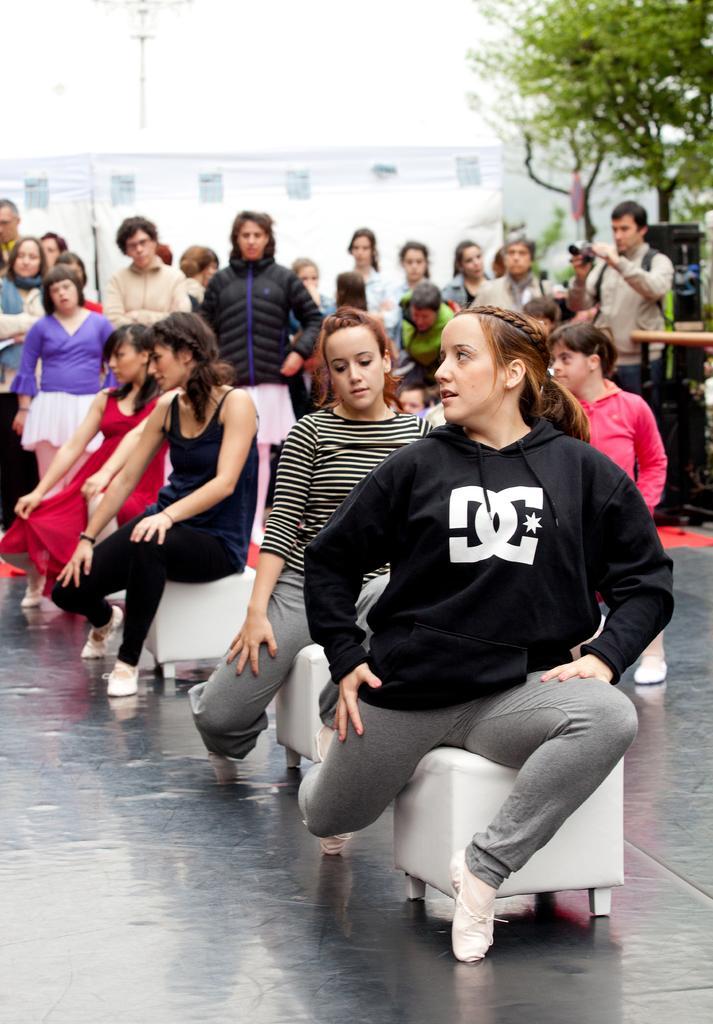Could you give a brief overview of what you see in this image? In this picture I can see the path in front, on which there are few people sitting on white colored stools and rest of them are sitting are standing. In the background I can see a building and few trees. On the right side of this image I can see a man holding a thing. 